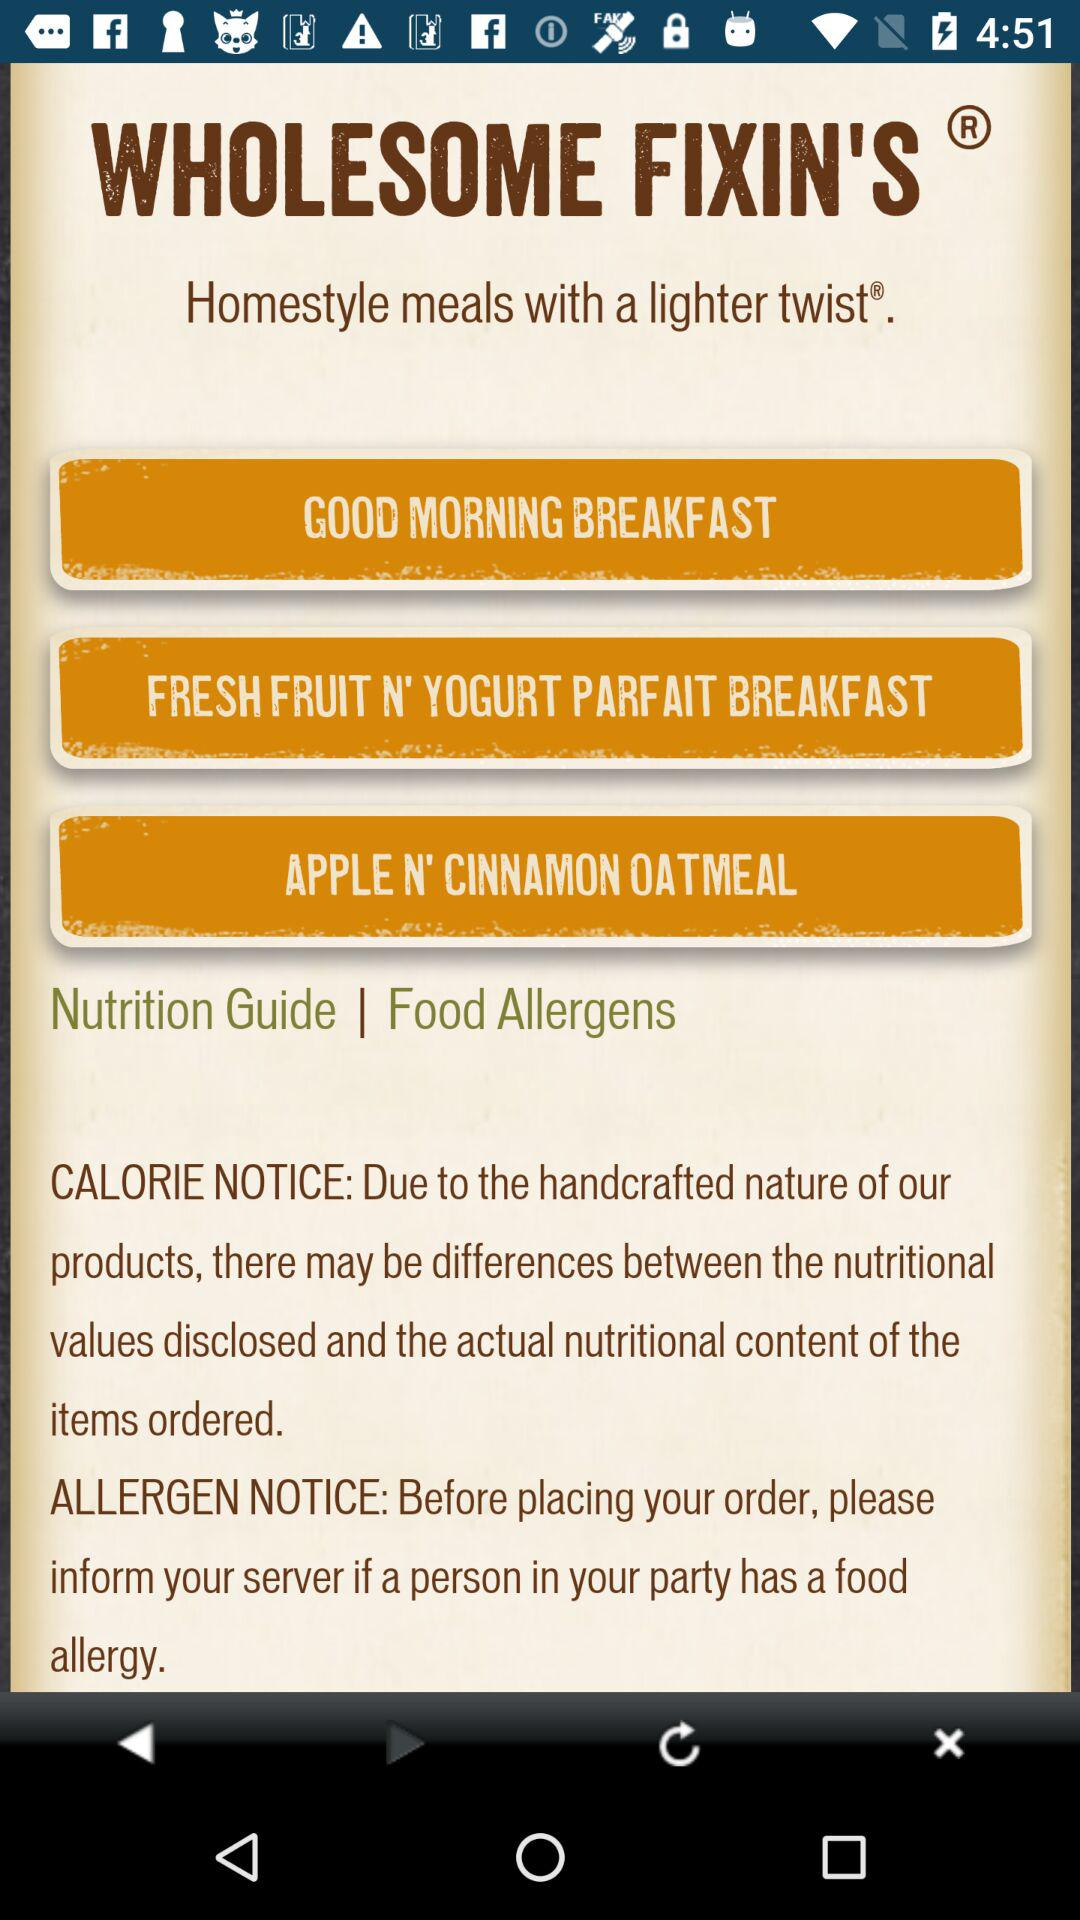What options are there for home style meals? The options are "GOOD MORNING BREAKFAST", "FRESH FRUIT N' YOGURT PARFAIT BREAKFAST" and "APPLE N' CINNAMON OATMEAL". 